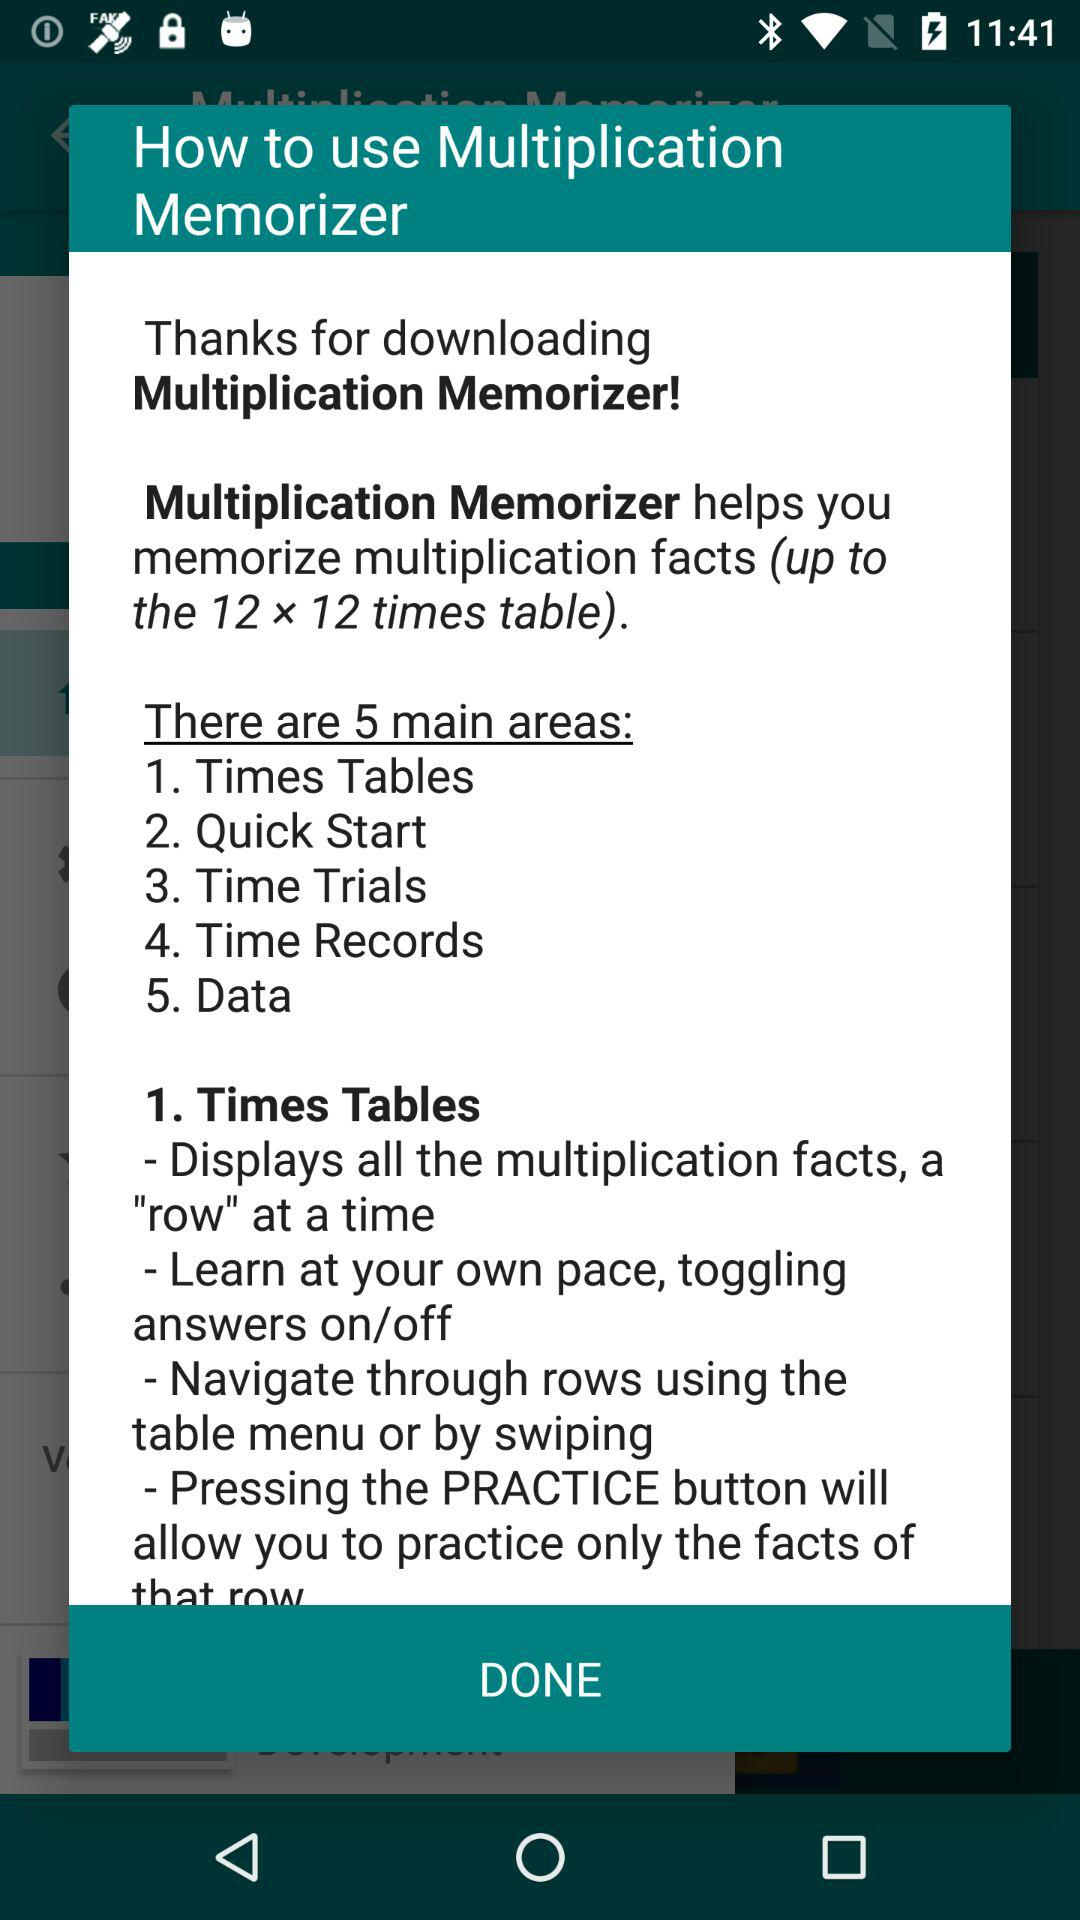What is the application name? The application name is "Multiplication Memorizer". 